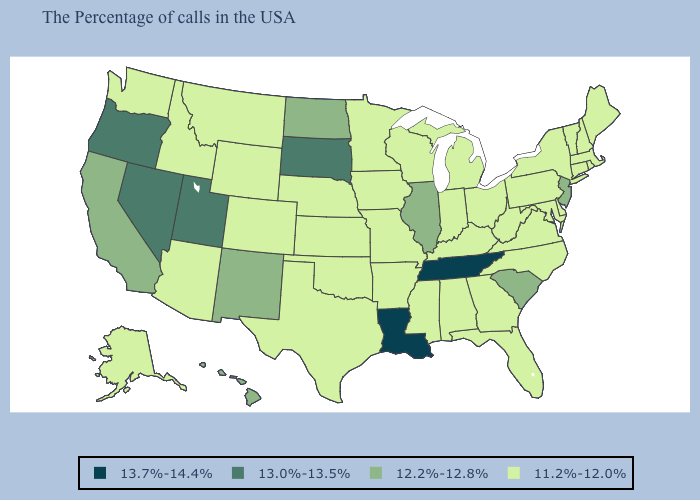Name the states that have a value in the range 13.7%-14.4%?
Write a very short answer. Tennessee, Louisiana. Does Delaware have a higher value than Nebraska?
Short answer required. No. Does Utah have a higher value than West Virginia?
Give a very brief answer. Yes. Name the states that have a value in the range 12.2%-12.8%?
Concise answer only. New Jersey, South Carolina, Illinois, North Dakota, New Mexico, California, Hawaii. What is the value of Missouri?
Concise answer only. 11.2%-12.0%. Among the states that border Massachusetts , which have the lowest value?
Quick response, please. Rhode Island, New Hampshire, Vermont, Connecticut, New York. What is the value of North Dakota?
Give a very brief answer. 12.2%-12.8%. Name the states that have a value in the range 11.2%-12.0%?
Short answer required. Maine, Massachusetts, Rhode Island, New Hampshire, Vermont, Connecticut, New York, Delaware, Maryland, Pennsylvania, Virginia, North Carolina, West Virginia, Ohio, Florida, Georgia, Michigan, Kentucky, Indiana, Alabama, Wisconsin, Mississippi, Missouri, Arkansas, Minnesota, Iowa, Kansas, Nebraska, Oklahoma, Texas, Wyoming, Colorado, Montana, Arizona, Idaho, Washington, Alaska. Among the states that border Texas , does Arkansas have the lowest value?
Keep it brief. Yes. Which states have the lowest value in the USA?
Concise answer only. Maine, Massachusetts, Rhode Island, New Hampshire, Vermont, Connecticut, New York, Delaware, Maryland, Pennsylvania, Virginia, North Carolina, West Virginia, Ohio, Florida, Georgia, Michigan, Kentucky, Indiana, Alabama, Wisconsin, Mississippi, Missouri, Arkansas, Minnesota, Iowa, Kansas, Nebraska, Oklahoma, Texas, Wyoming, Colorado, Montana, Arizona, Idaho, Washington, Alaska. What is the highest value in states that border Virginia?
Write a very short answer. 13.7%-14.4%. What is the highest value in states that border Illinois?
Keep it brief. 11.2%-12.0%. What is the highest value in states that border New Hampshire?
Quick response, please. 11.2%-12.0%. 